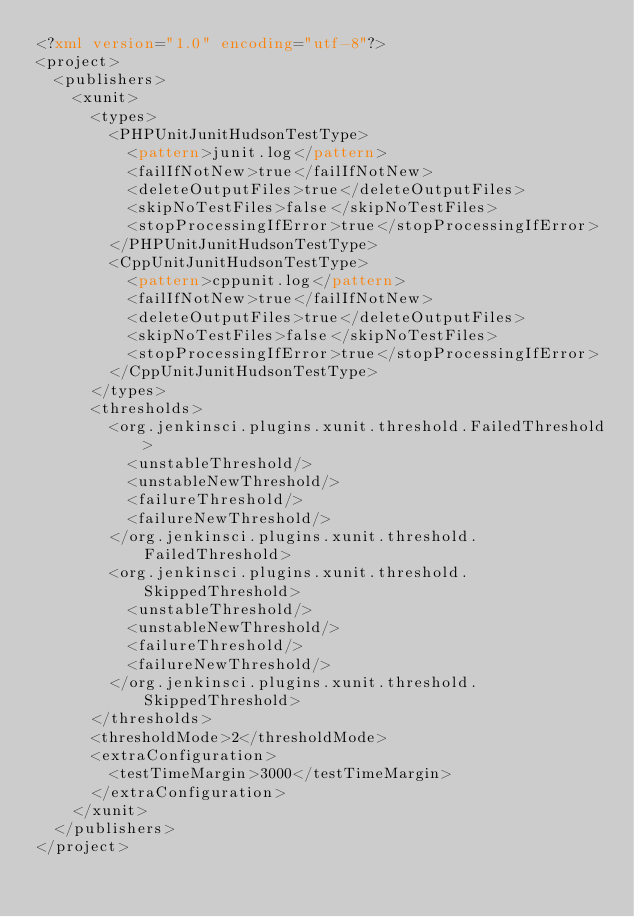Convert code to text. <code><loc_0><loc_0><loc_500><loc_500><_XML_><?xml version="1.0" encoding="utf-8"?>
<project>
  <publishers>
    <xunit>
      <types>
        <PHPUnitJunitHudsonTestType>
          <pattern>junit.log</pattern>
          <failIfNotNew>true</failIfNotNew>
          <deleteOutputFiles>true</deleteOutputFiles>
          <skipNoTestFiles>false</skipNoTestFiles>
          <stopProcessingIfError>true</stopProcessingIfError>
        </PHPUnitJunitHudsonTestType>
        <CppUnitJunitHudsonTestType>
          <pattern>cppunit.log</pattern>
          <failIfNotNew>true</failIfNotNew>
          <deleteOutputFiles>true</deleteOutputFiles>
          <skipNoTestFiles>false</skipNoTestFiles>
          <stopProcessingIfError>true</stopProcessingIfError>
        </CppUnitJunitHudsonTestType>
      </types>
      <thresholds>
        <org.jenkinsci.plugins.xunit.threshold.FailedThreshold>
          <unstableThreshold/>
          <unstableNewThreshold/>
          <failureThreshold/>
          <failureNewThreshold/>
        </org.jenkinsci.plugins.xunit.threshold.FailedThreshold>
        <org.jenkinsci.plugins.xunit.threshold.SkippedThreshold>
          <unstableThreshold/>
          <unstableNewThreshold/>
          <failureThreshold/>
          <failureNewThreshold/>
        </org.jenkinsci.plugins.xunit.threshold.SkippedThreshold>
      </thresholds>
      <thresholdMode>2</thresholdMode>
      <extraConfiguration>
        <testTimeMargin>3000</testTimeMargin>
      </extraConfiguration>
    </xunit>
  </publishers>
</project>
</code> 